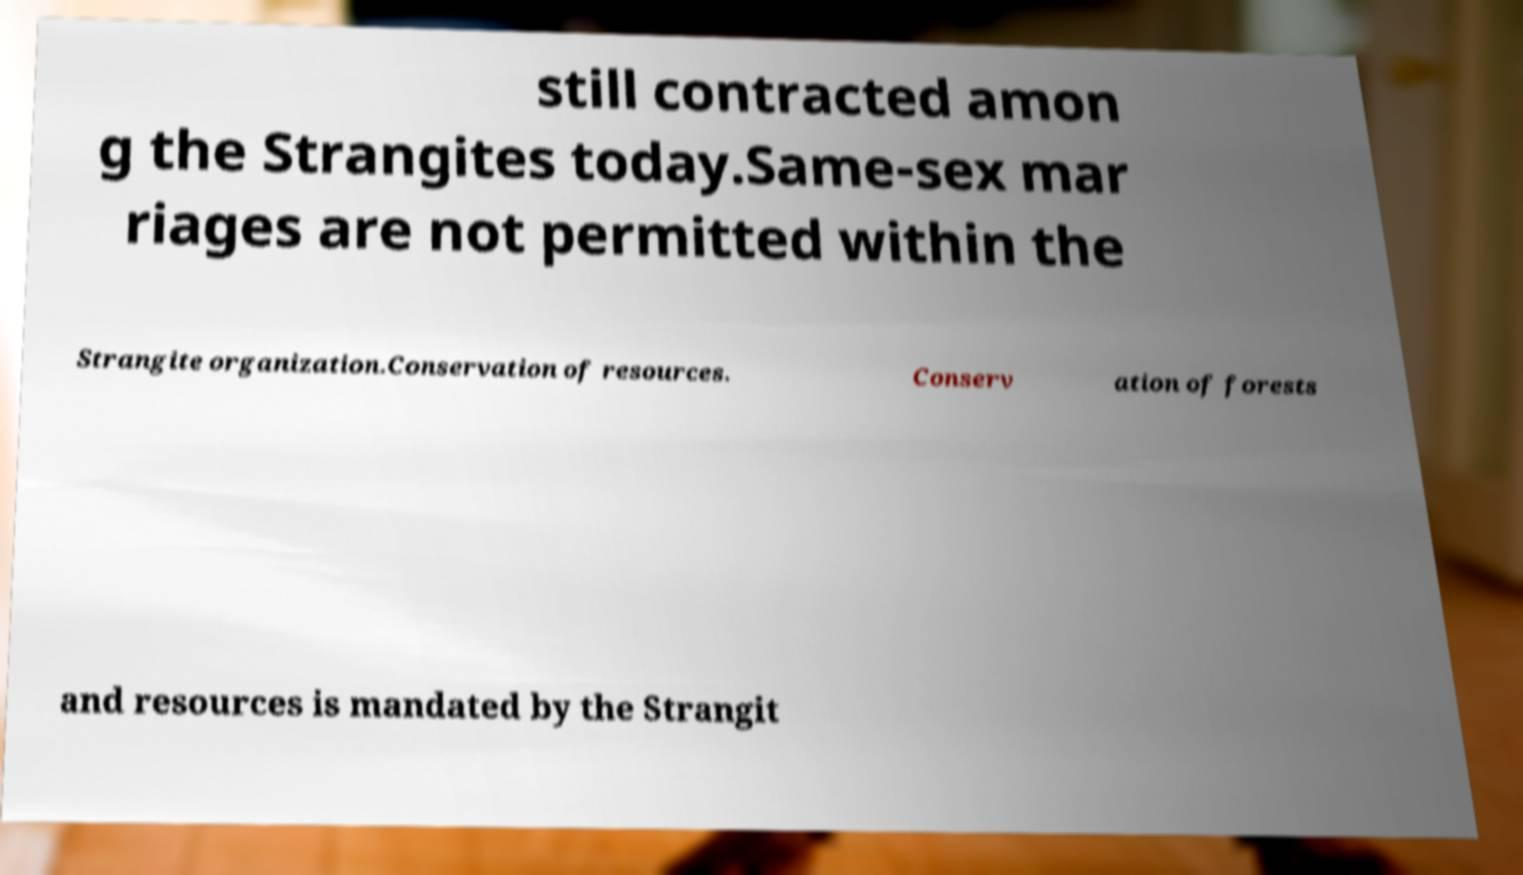For documentation purposes, I need the text within this image transcribed. Could you provide that? still contracted amon g the Strangites today.Same-sex mar riages are not permitted within the Strangite organization.Conservation of resources. Conserv ation of forests and resources is mandated by the Strangit 